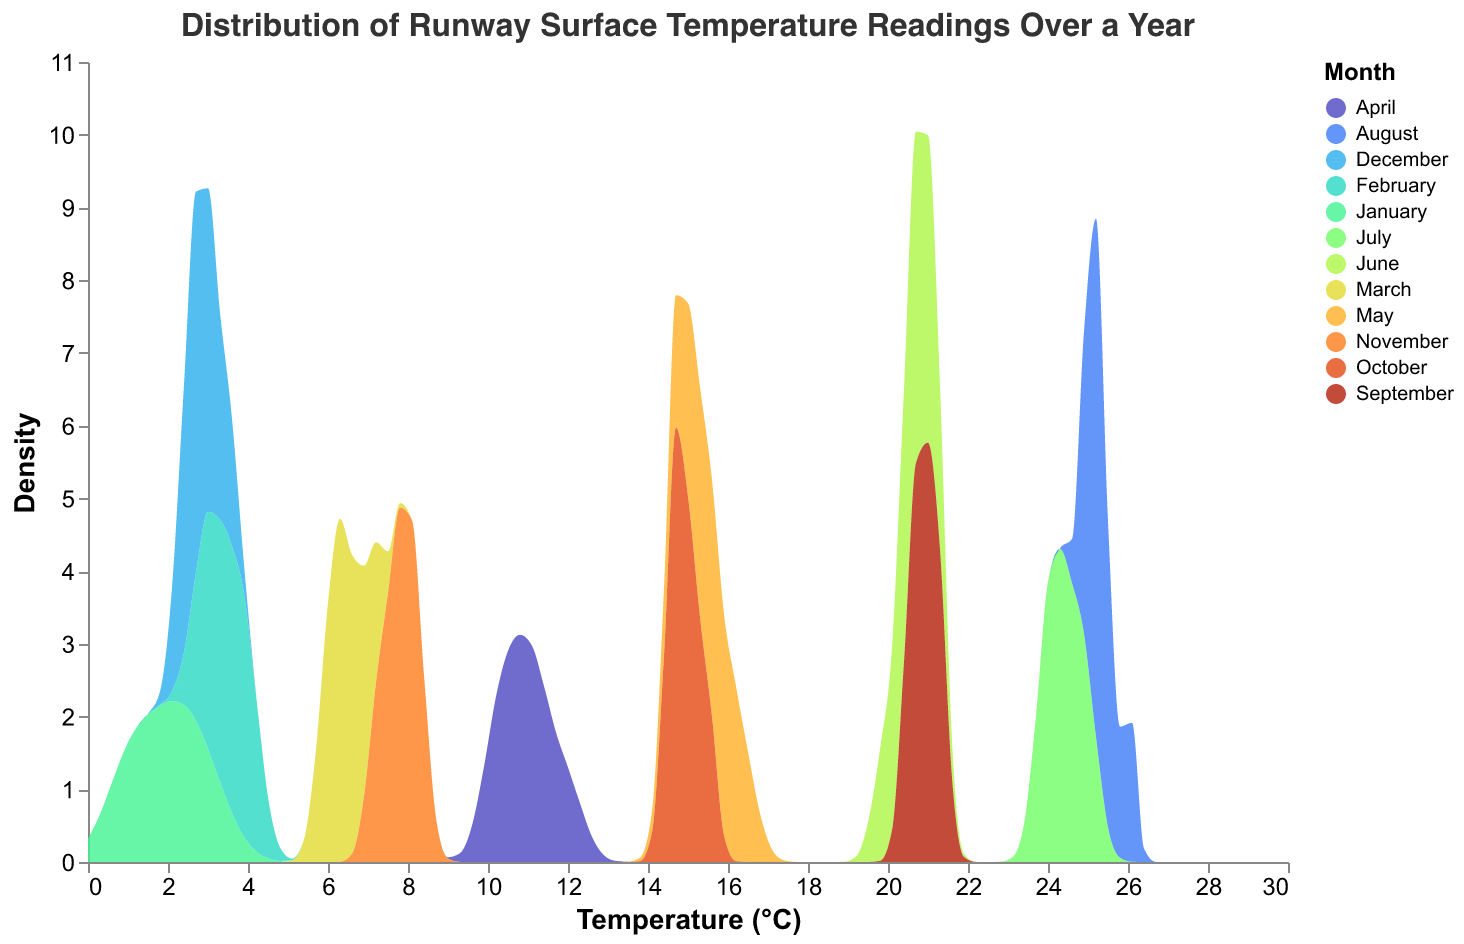What is the title of the figure? The title is usually found at the top of the figure and describes what the figure is about, allowing one to understand the context at a glance.
Answer: Distribution of Runway Surface Temperature Readings Over a Year Which month shows the highest temperature readings? By observing the peaks in the density distribution, August can be identified as showing the highest temperature readings. This can be deduced from the highest peaks in the distribution curves.
Answer: August How do the temperature distributions in January and July compare? Comparing the density distributions, January shows lower temperature readings clustered around 2-3°C while July shows higher temperatures around 24-25°C. The distributions don’t overlap, highlighting seasonal variations.
Answer: January: 2-3°C, July: 24-25°C Which month has the widest range of temperature readings? A wider range in the density distribution curve indicates greater variability in temperature readings. By observing the width of the density curves, March appears to have the widest range in temperature readings.
Answer: March During which month do most temperature readings lie around 15°C? By looking at the density peaks centered around 15°C, May and October both have temperature readings lying around 15°C, with prominent peaks in this region.
Answer: May and October What is the general trend of temperature changes from January to December? Observing the density distributions from January to December, temperatures generally increase from winter to summer, peaking in August, and then decrease towards the end of the year.
Answer: Increase → Peak → Decrease Which month has the lowest temperature density peak? The density peak representing the lowest temperature readings can be identified in January, with peaks around 2-3°C. This can be determined by comparing the heights and positions of the density peaks.
Answer: January How similar are the temperature distributions for September and June? Comparing the density curves, September and June both show temperature peaks around 20-21°C. However, September has a slightly broader distribution compared to June.
Answer: Similar, with slight variations Which months' temperature distributions overlap? By examining the density curves, it is evident that the temperature distributions for April and May overlap around 14-16°C. Both months have similar temperature densities in this range.
Answer: April and May In which months are temperature readings most consistent? Consistency in temperature can be inferred from narrower peaks in the density distributions. July and August exhibit the most consistent temperatures with narrow peaks around 24-26°C.
Answer: July and August 